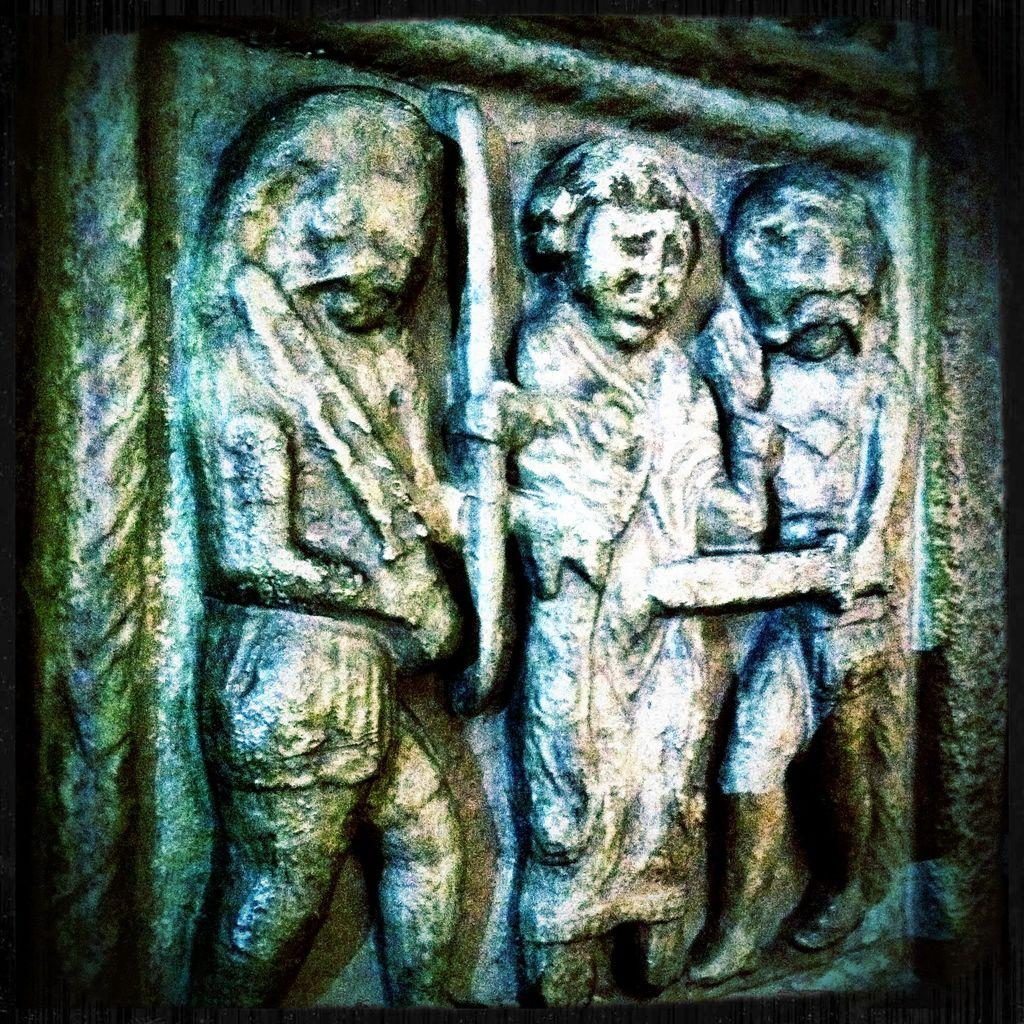What is present on the wall in the image? There are sculptures on the wall in the image. What type of leaf is being distributed by the hot air balloon in the image? There is no hot air balloon or leaf present in the image; it only features sculptures on the wall. 